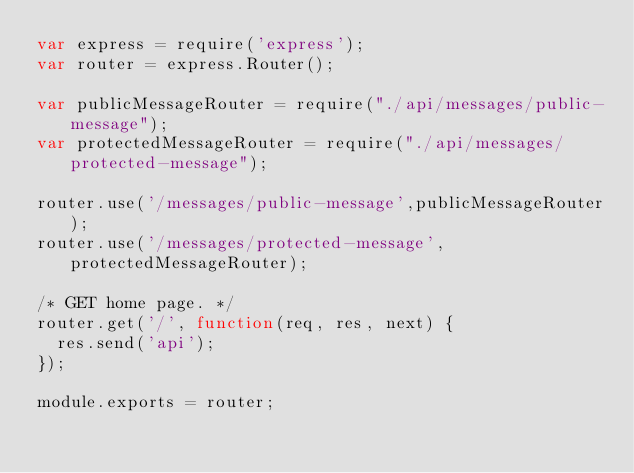Convert code to text. <code><loc_0><loc_0><loc_500><loc_500><_JavaScript_>var express = require('express');
var router = express.Router();

var publicMessageRouter = require("./api/messages/public-message");
var protectedMessageRouter = require("./api/messages/protected-message");

router.use('/messages/public-message',publicMessageRouter);
router.use('/messages/protected-message',protectedMessageRouter);

/* GET home page. */
router.get('/', function(req, res, next) {
  res.send('api');
});

module.exports = router;
</code> 